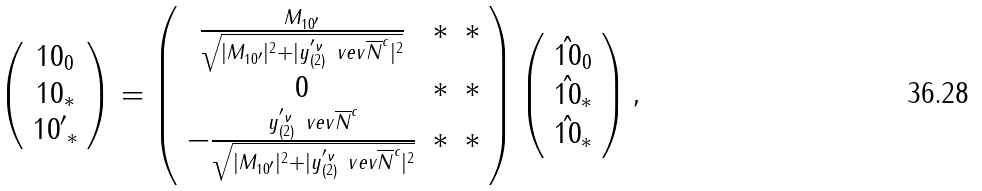<formula> <loc_0><loc_0><loc_500><loc_500>\left ( \begin{array} { c } { 1 0 } _ { 0 } \\ { 1 0 } _ { * } \\ { { 1 0 } ^ { \prime } } _ { * } \end{array} \right ) = \left ( \begin{array} { c c c } \frac { M _ { { 1 0 } ^ { \prime } } } { \sqrt { | M _ { { 1 0 } ^ { \prime } } | ^ { 2 } + | y ^ { ^ { \prime } \nu } _ { ( 2 ) } \ v e v { \overline { N } ^ { c } } | ^ { 2 } } } & * & * \\ 0 & * & * \\ - \frac { y ^ { ^ { \prime } \nu } _ { ( 2 ) } \ v e v { \overline { N } ^ { c } } } { \sqrt { | M _ { { 1 0 } ^ { \prime } } | ^ { 2 } + | y ^ { ^ { \prime } \nu } _ { ( 2 ) } \ v e v { \overline { N } ^ { c } } | ^ { 2 } } } & * & * \end{array} \right ) \left ( \begin{array} { c } \hat { 1 0 } _ { 0 } \\ \hat { 1 0 } _ { * } \\ { \hat { 1 0 } } _ { * } \end{array} \right ) ,</formula> 